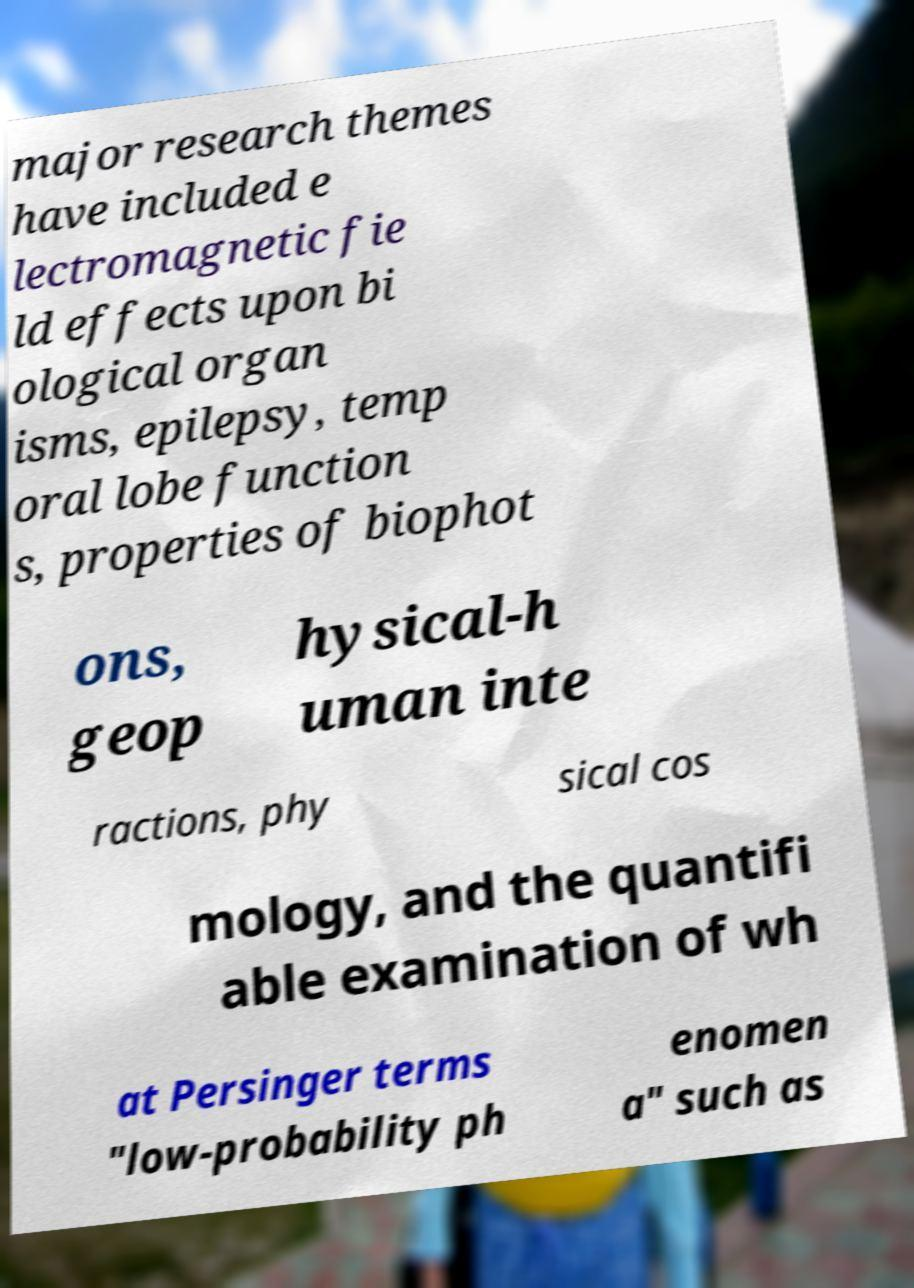Please read and relay the text visible in this image. What does it say? major research themes have included e lectromagnetic fie ld effects upon bi ological organ isms, epilepsy, temp oral lobe function s, properties of biophot ons, geop hysical-h uman inte ractions, phy sical cos mology, and the quantifi able examination of wh at Persinger terms "low-probability ph enomen a" such as 